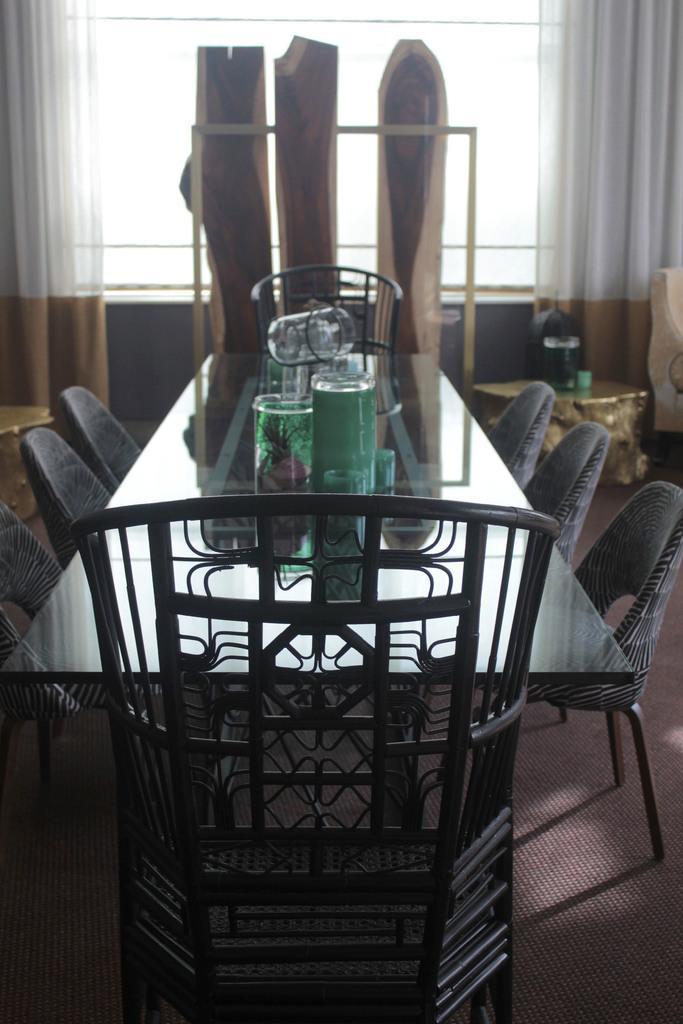Could you give a brief overview of what you see in this image? In the center of the image there is a table and chairs. We can see glasses and a tray placed on the table. In the background there is a window and curtains. On the right we can see a stand and there are things placed on the stand. 